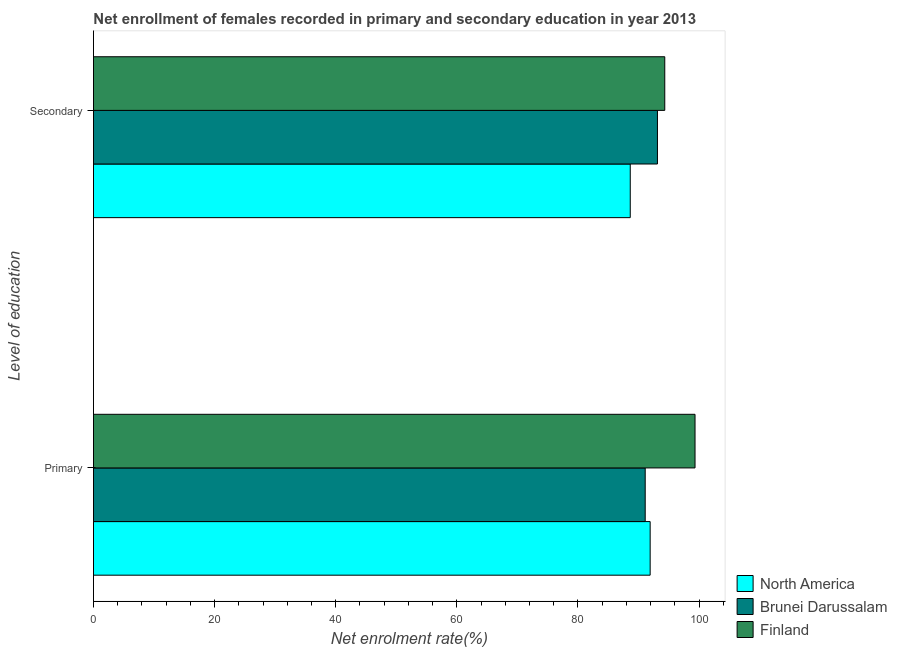How many different coloured bars are there?
Your response must be concise. 3. Are the number of bars per tick equal to the number of legend labels?
Offer a very short reply. Yes. How many bars are there on the 1st tick from the bottom?
Provide a succinct answer. 3. What is the label of the 2nd group of bars from the top?
Ensure brevity in your answer.  Primary. What is the enrollment rate in primary education in Finland?
Ensure brevity in your answer.  99.33. Across all countries, what is the maximum enrollment rate in primary education?
Your answer should be compact. 99.33. Across all countries, what is the minimum enrollment rate in primary education?
Your answer should be very brief. 91.1. In which country was the enrollment rate in secondary education maximum?
Keep it short and to the point. Finland. In which country was the enrollment rate in primary education minimum?
Provide a succinct answer. Brunei Darussalam. What is the total enrollment rate in primary education in the graph?
Provide a short and direct response. 282.36. What is the difference between the enrollment rate in secondary education in Finland and that in North America?
Provide a short and direct response. 5.7. What is the difference between the enrollment rate in primary education in Brunei Darussalam and the enrollment rate in secondary education in North America?
Your answer should be compact. 2.47. What is the average enrollment rate in primary education per country?
Your response must be concise. 94.12. What is the difference between the enrollment rate in secondary education and enrollment rate in primary education in North America?
Offer a terse response. -3.29. In how many countries, is the enrollment rate in primary education greater than 52 %?
Offer a very short reply. 3. What is the ratio of the enrollment rate in primary education in Brunei Darussalam to that in Finland?
Your response must be concise. 0.92. In how many countries, is the enrollment rate in primary education greater than the average enrollment rate in primary education taken over all countries?
Your answer should be compact. 1. How many bars are there?
Give a very brief answer. 6. What is the difference between two consecutive major ticks on the X-axis?
Your response must be concise. 20. Are the values on the major ticks of X-axis written in scientific E-notation?
Make the answer very short. No. How are the legend labels stacked?
Ensure brevity in your answer.  Vertical. What is the title of the graph?
Ensure brevity in your answer.  Net enrollment of females recorded in primary and secondary education in year 2013. What is the label or title of the X-axis?
Provide a succinct answer. Net enrolment rate(%). What is the label or title of the Y-axis?
Provide a succinct answer. Level of education. What is the Net enrolment rate(%) of North America in Primary?
Your answer should be very brief. 91.92. What is the Net enrolment rate(%) of Brunei Darussalam in Primary?
Your answer should be compact. 91.1. What is the Net enrolment rate(%) in Finland in Primary?
Keep it short and to the point. 99.33. What is the Net enrolment rate(%) of North America in Secondary?
Keep it short and to the point. 88.64. What is the Net enrolment rate(%) in Brunei Darussalam in Secondary?
Offer a terse response. 93.13. What is the Net enrolment rate(%) of Finland in Secondary?
Provide a short and direct response. 94.33. Across all Level of education, what is the maximum Net enrolment rate(%) in North America?
Your answer should be very brief. 91.92. Across all Level of education, what is the maximum Net enrolment rate(%) in Brunei Darussalam?
Give a very brief answer. 93.13. Across all Level of education, what is the maximum Net enrolment rate(%) of Finland?
Provide a short and direct response. 99.33. Across all Level of education, what is the minimum Net enrolment rate(%) of North America?
Your answer should be compact. 88.64. Across all Level of education, what is the minimum Net enrolment rate(%) of Brunei Darussalam?
Provide a short and direct response. 91.1. Across all Level of education, what is the minimum Net enrolment rate(%) of Finland?
Your response must be concise. 94.33. What is the total Net enrolment rate(%) in North America in the graph?
Keep it short and to the point. 180.56. What is the total Net enrolment rate(%) of Brunei Darussalam in the graph?
Keep it short and to the point. 184.23. What is the total Net enrolment rate(%) of Finland in the graph?
Give a very brief answer. 193.66. What is the difference between the Net enrolment rate(%) in North America in Primary and that in Secondary?
Your answer should be compact. 3.29. What is the difference between the Net enrolment rate(%) of Brunei Darussalam in Primary and that in Secondary?
Your answer should be very brief. -2.02. What is the difference between the Net enrolment rate(%) in Finland in Primary and that in Secondary?
Keep it short and to the point. 5. What is the difference between the Net enrolment rate(%) in North America in Primary and the Net enrolment rate(%) in Brunei Darussalam in Secondary?
Your answer should be very brief. -1.2. What is the difference between the Net enrolment rate(%) of North America in Primary and the Net enrolment rate(%) of Finland in Secondary?
Give a very brief answer. -2.41. What is the difference between the Net enrolment rate(%) in Brunei Darussalam in Primary and the Net enrolment rate(%) in Finland in Secondary?
Your answer should be very brief. -3.23. What is the average Net enrolment rate(%) in North America per Level of education?
Your answer should be compact. 90.28. What is the average Net enrolment rate(%) of Brunei Darussalam per Level of education?
Offer a terse response. 92.12. What is the average Net enrolment rate(%) of Finland per Level of education?
Your answer should be compact. 96.83. What is the difference between the Net enrolment rate(%) of North America and Net enrolment rate(%) of Brunei Darussalam in Primary?
Offer a very short reply. 0.82. What is the difference between the Net enrolment rate(%) in North America and Net enrolment rate(%) in Finland in Primary?
Your answer should be very brief. -7.41. What is the difference between the Net enrolment rate(%) of Brunei Darussalam and Net enrolment rate(%) of Finland in Primary?
Ensure brevity in your answer.  -8.23. What is the difference between the Net enrolment rate(%) of North America and Net enrolment rate(%) of Brunei Darussalam in Secondary?
Your response must be concise. -4.49. What is the difference between the Net enrolment rate(%) of North America and Net enrolment rate(%) of Finland in Secondary?
Offer a very short reply. -5.7. What is the difference between the Net enrolment rate(%) of Brunei Darussalam and Net enrolment rate(%) of Finland in Secondary?
Offer a very short reply. -1.21. What is the ratio of the Net enrolment rate(%) of North America in Primary to that in Secondary?
Provide a short and direct response. 1.04. What is the ratio of the Net enrolment rate(%) of Brunei Darussalam in Primary to that in Secondary?
Your response must be concise. 0.98. What is the ratio of the Net enrolment rate(%) of Finland in Primary to that in Secondary?
Provide a short and direct response. 1.05. What is the difference between the highest and the second highest Net enrolment rate(%) of North America?
Offer a very short reply. 3.29. What is the difference between the highest and the second highest Net enrolment rate(%) in Brunei Darussalam?
Offer a terse response. 2.02. What is the difference between the highest and the second highest Net enrolment rate(%) in Finland?
Offer a very short reply. 5. What is the difference between the highest and the lowest Net enrolment rate(%) in North America?
Offer a terse response. 3.29. What is the difference between the highest and the lowest Net enrolment rate(%) in Brunei Darussalam?
Make the answer very short. 2.02. What is the difference between the highest and the lowest Net enrolment rate(%) in Finland?
Provide a short and direct response. 5. 